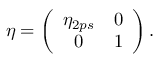Convert formula to latex. <formula><loc_0><loc_0><loc_500><loc_500>\eta = \left ( \begin{array} { c c } { { \eta _ { 2 p s } } } & { 0 } \\ { 0 } & { 1 } \end{array} \right ) .</formula> 